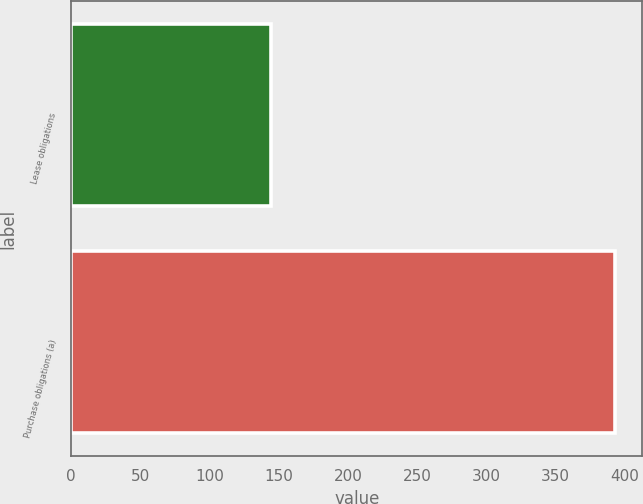Convert chart. <chart><loc_0><loc_0><loc_500><loc_500><bar_chart><fcel>Lease obligations<fcel>Purchase obligations (a)<nl><fcel>144<fcel>393<nl></chart> 